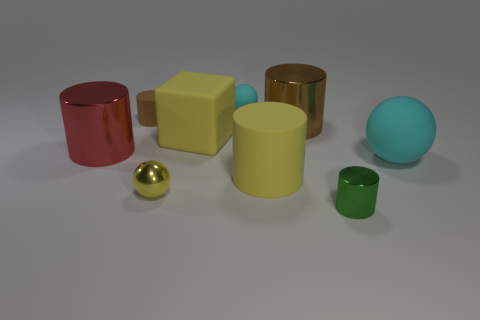The tiny green thing that is made of the same material as the red cylinder is what shape?
Keep it short and to the point. Cylinder. Are there any other things of the same color as the rubber cube?
Give a very brief answer. Yes. What is the material of the brown thing on the right side of the big matte thing behind the big ball?
Ensure brevity in your answer.  Metal. Is there a small yellow metallic thing of the same shape as the green metal object?
Offer a very short reply. No. What number of other objects are there of the same shape as the big cyan thing?
Give a very brief answer. 2. There is a tiny thing that is both on the left side of the tiny cyan matte object and in front of the tiny brown rubber cylinder; what shape is it?
Offer a very short reply. Sphere. How big is the rubber sphere that is in front of the brown metallic cylinder?
Ensure brevity in your answer.  Large. Is the size of the yellow rubber cube the same as the red metal cylinder?
Keep it short and to the point. Yes. Are there fewer tiny yellow shiny balls that are on the right side of the big matte block than rubber blocks on the right side of the tiny green object?
Your response must be concise. No. What is the size of the sphere that is behind the yellow cylinder and on the left side of the large cyan matte object?
Give a very brief answer. Small. 